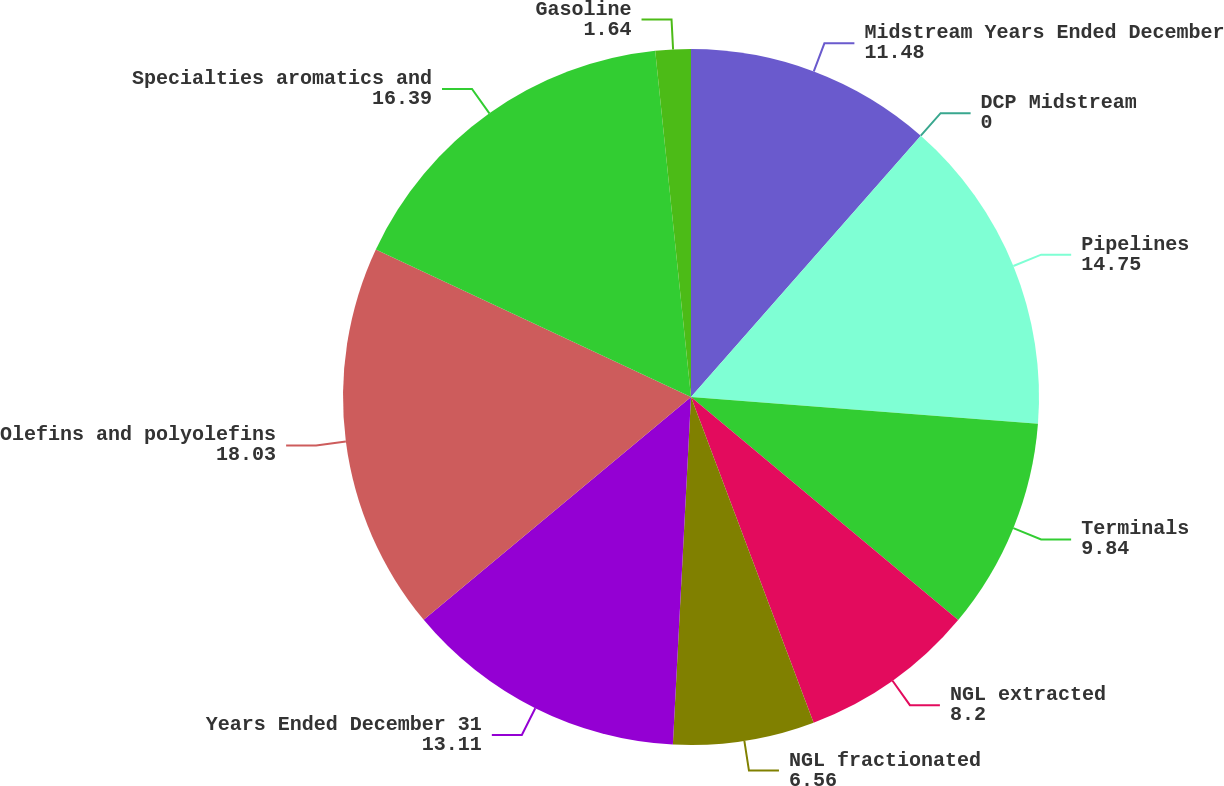<chart> <loc_0><loc_0><loc_500><loc_500><pie_chart><fcel>Midstream Years Ended December<fcel>DCP Midstream<fcel>Pipelines<fcel>Terminals<fcel>NGL extracted<fcel>NGL fractionated<fcel>Years Ended December 31<fcel>Olefins and polyolefins<fcel>Specialties aromatics and<fcel>Gasoline<nl><fcel>11.48%<fcel>0.0%<fcel>14.75%<fcel>9.84%<fcel>8.2%<fcel>6.56%<fcel>13.11%<fcel>18.03%<fcel>16.39%<fcel>1.64%<nl></chart> 